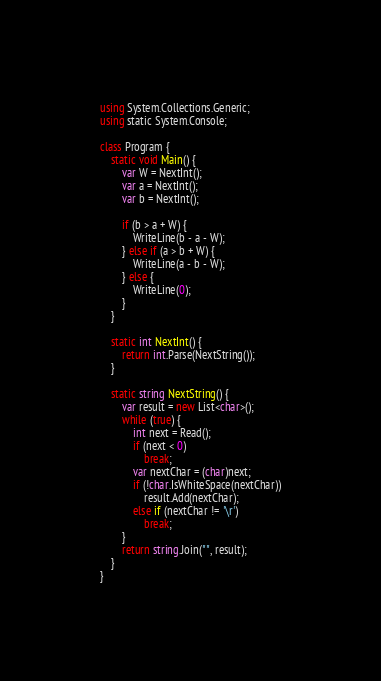Convert code to text. <code><loc_0><loc_0><loc_500><loc_500><_C#_>using System.Collections.Generic;
using static System.Console;

class Program {
	static void Main() {
		var W = NextInt();
		var a = NextInt();
		var b = NextInt();

		if (b > a + W) {
			WriteLine(b - a - W);
		} else if (a > b + W) {
			WriteLine(a - b - W);
		} else {
			WriteLine(0);
		}
	}

	static int NextInt() {
		return int.Parse(NextString());
	}

	static string NextString() {
		var result = new List<char>();
		while (true) {
			int next = Read();
			if (next < 0)
				break;
			var nextChar = (char)next;
			if (!char.IsWhiteSpace(nextChar))
				result.Add(nextChar);
			else if (nextChar != '\r')
				break;
		}
		return string.Join("", result);
	}
}
</code> 